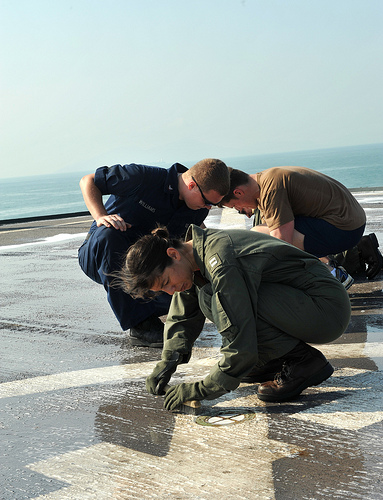<image>
Is the ground under the paint? Yes. The ground is positioned underneath the paint, with the paint above it in the vertical space. 